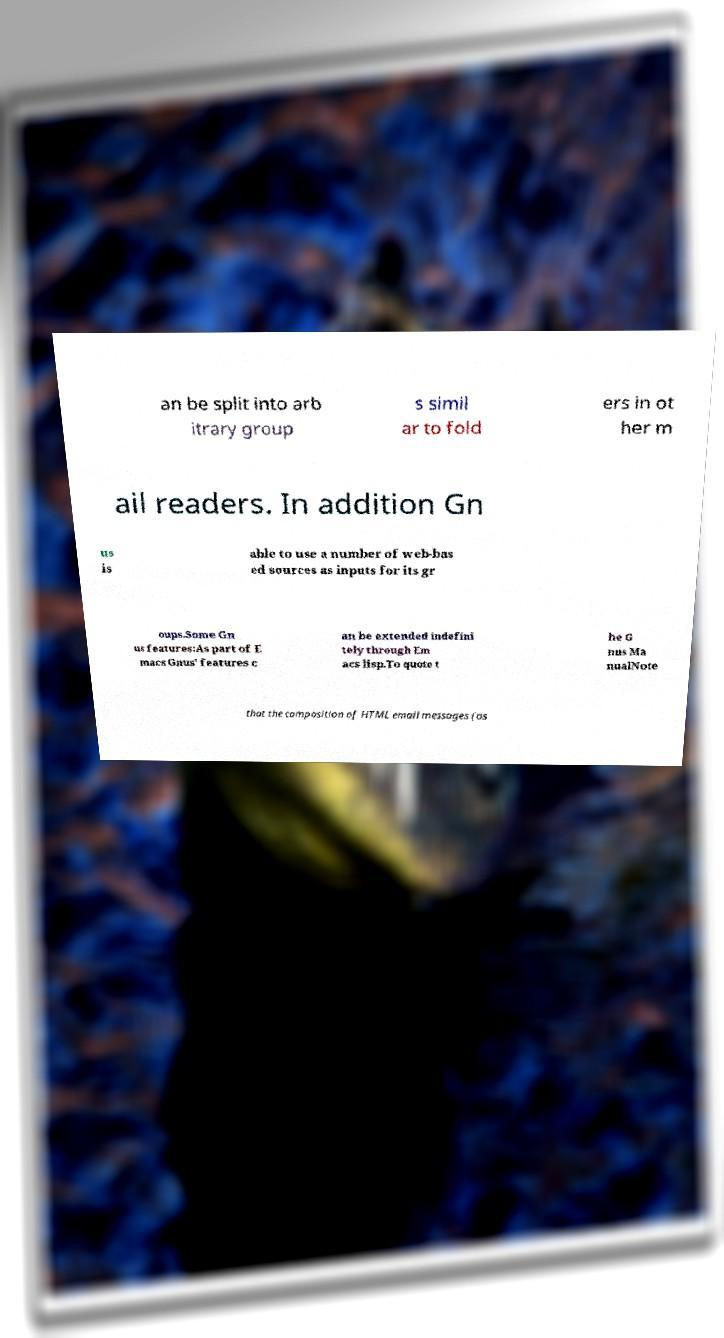Please identify and transcribe the text found in this image. an be split into arb itrary group s simil ar to fold ers in ot her m ail readers. In addition Gn us is able to use a number of web-bas ed sources as inputs for its gr oups.Some Gn us features:As part of E macs Gnus' features c an be extended indefini tely through Em acs lisp.To quote t he G nus Ma nualNote that the composition of HTML email messages (as 